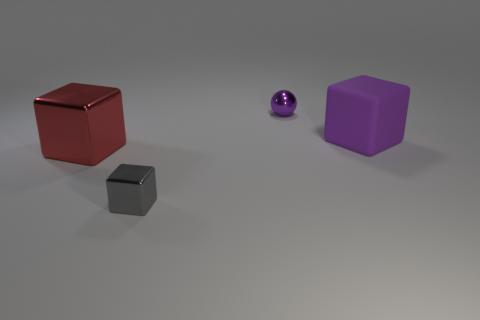Is the number of matte objects behind the large purple matte cube greater than the number of large rubber cubes on the right side of the small purple object?
Ensure brevity in your answer.  No. There is a big rubber cube; does it have the same color as the tiny object to the left of the small purple shiny sphere?
Provide a succinct answer. No. What material is the thing that is the same size as the purple block?
Your response must be concise. Metal. How many objects are either brown matte cubes or shiny cubes in front of the large red metal block?
Ensure brevity in your answer.  1. There is a purple matte cube; is its size the same as the red metallic object on the left side of the metallic ball?
Your answer should be compact. Yes. How many cylinders are cyan metal things or tiny shiny things?
Provide a short and direct response. 0. What number of big blocks are both left of the gray object and to the right of the tiny cube?
Provide a short and direct response. 0. What number of other things are the same color as the matte cube?
Your answer should be very brief. 1. The small thing left of the tiny purple shiny sphere has what shape?
Ensure brevity in your answer.  Cube. Does the small purple ball have the same material as the big purple thing?
Your answer should be very brief. No. 